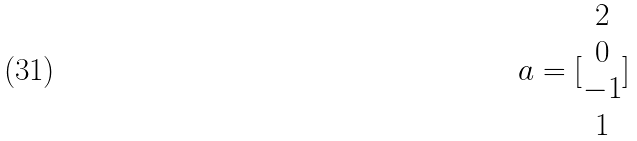<formula> <loc_0><loc_0><loc_500><loc_500>a = [ \begin{matrix} 2 \\ 0 \\ - 1 \\ 1 \end{matrix} ]</formula> 